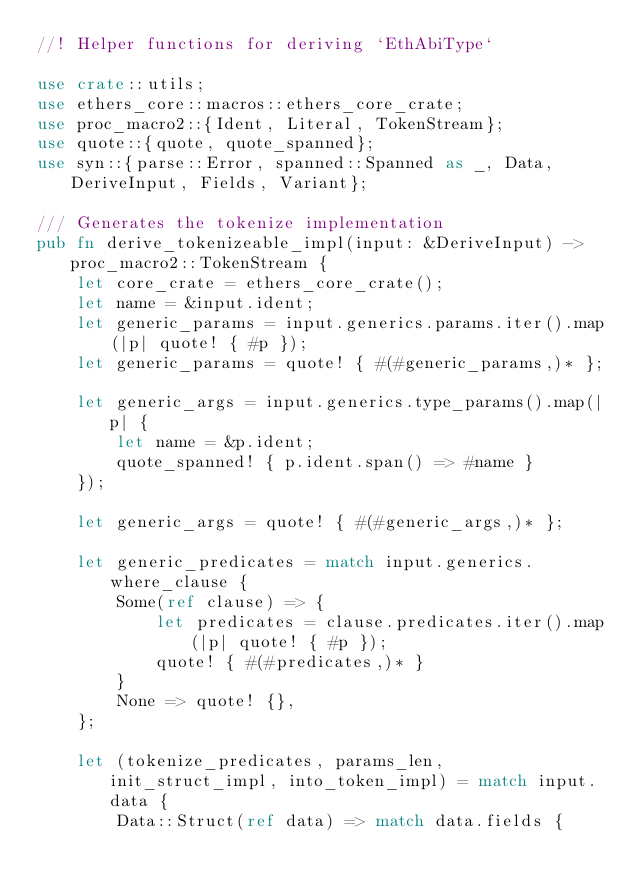<code> <loc_0><loc_0><loc_500><loc_500><_Rust_>//! Helper functions for deriving `EthAbiType`

use crate::utils;
use ethers_core::macros::ethers_core_crate;
use proc_macro2::{Ident, Literal, TokenStream};
use quote::{quote, quote_spanned};
use syn::{parse::Error, spanned::Spanned as _, Data, DeriveInput, Fields, Variant};

/// Generates the tokenize implementation
pub fn derive_tokenizeable_impl(input: &DeriveInput) -> proc_macro2::TokenStream {
    let core_crate = ethers_core_crate();
    let name = &input.ident;
    let generic_params = input.generics.params.iter().map(|p| quote! { #p });
    let generic_params = quote! { #(#generic_params,)* };

    let generic_args = input.generics.type_params().map(|p| {
        let name = &p.ident;
        quote_spanned! { p.ident.span() => #name }
    });

    let generic_args = quote! { #(#generic_args,)* };

    let generic_predicates = match input.generics.where_clause {
        Some(ref clause) => {
            let predicates = clause.predicates.iter().map(|p| quote! { #p });
            quote! { #(#predicates,)* }
        }
        None => quote! {},
    };

    let (tokenize_predicates, params_len, init_struct_impl, into_token_impl) = match input.data {
        Data::Struct(ref data) => match data.fields {</code> 